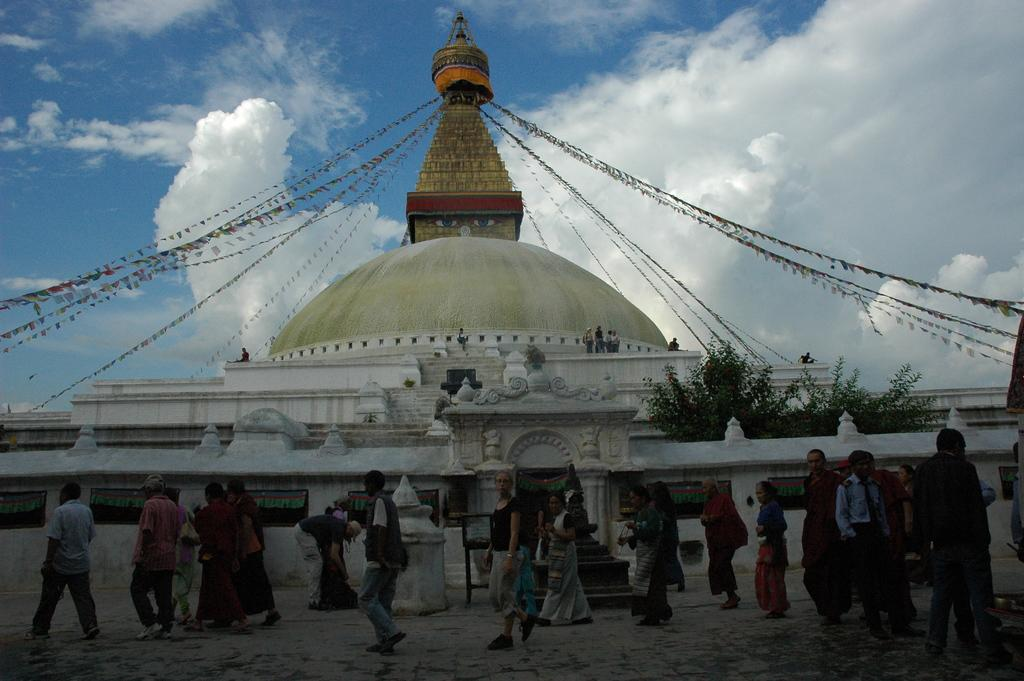What type of structure is visible in the image? There is a building in the image. Where are people located in the image? People are standing on the building and on the floor. What type of vegetation can be seen in the image? There are trees in the image. What additional elements are present in the image? Decorations are present in the image. What is visible in the background of the image? The sky is visible in the image, and clouds are present in the sky. What type of alley can be seen in the image? There is no alley present in the image. Can you tell me how many chess pieces are on the building? There is no chess game or pieces visible in the image. 